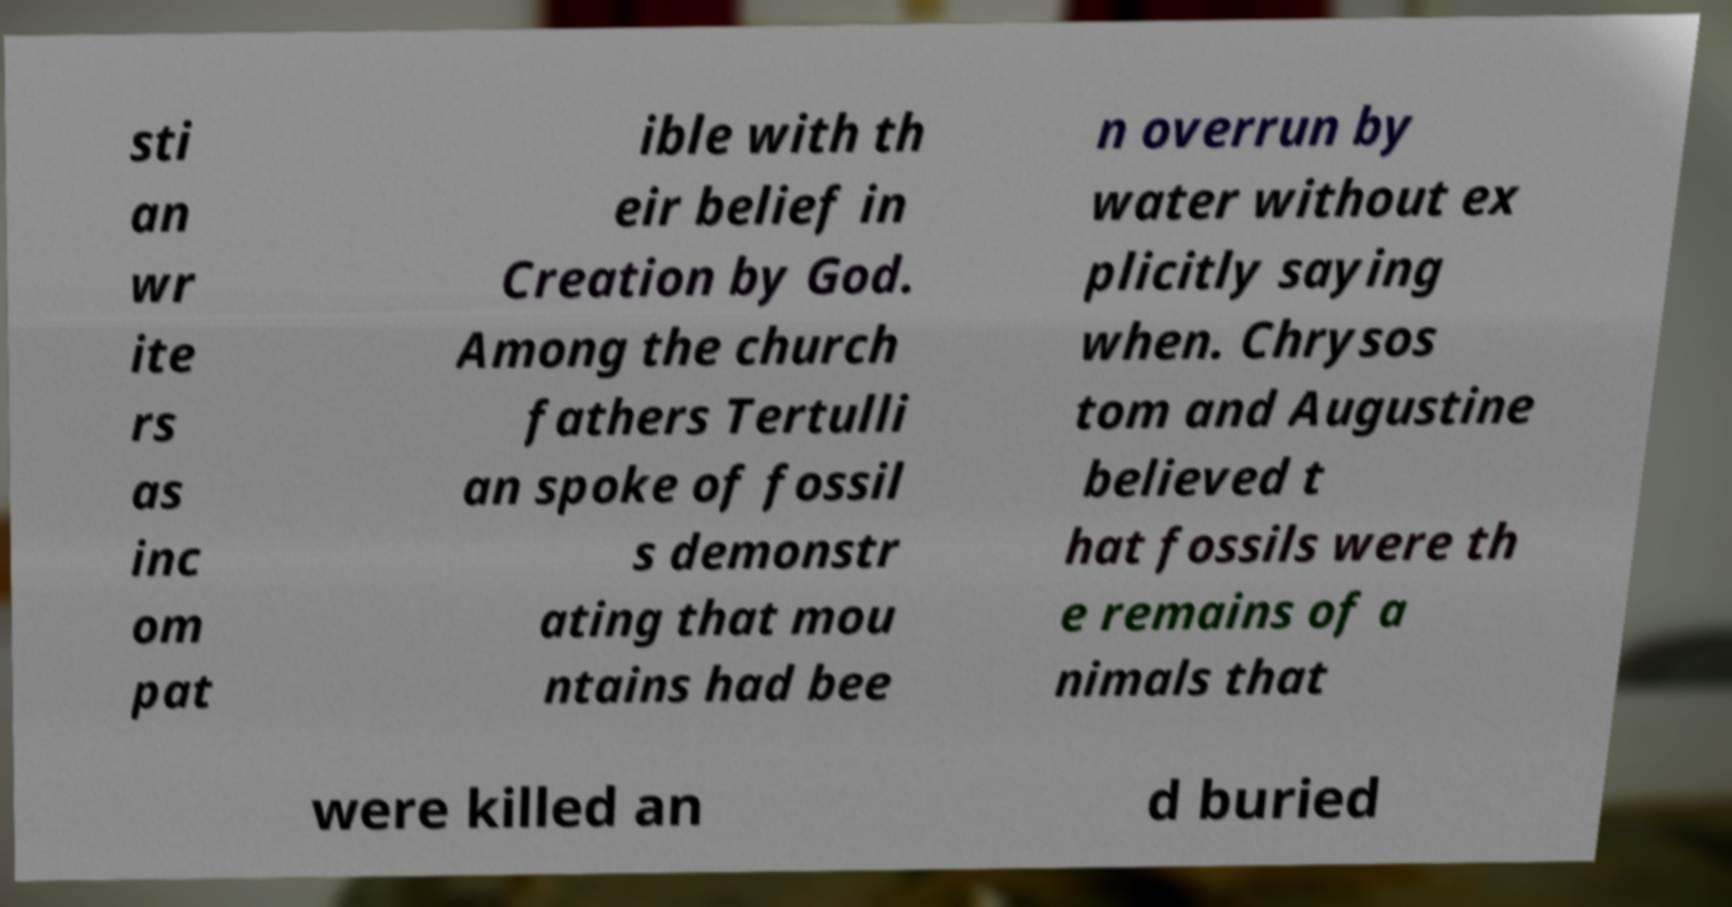Please read and relay the text visible in this image. What does it say? sti an wr ite rs as inc om pat ible with th eir belief in Creation by God. Among the church fathers Tertulli an spoke of fossil s demonstr ating that mou ntains had bee n overrun by water without ex plicitly saying when. Chrysos tom and Augustine believed t hat fossils were th e remains of a nimals that were killed an d buried 